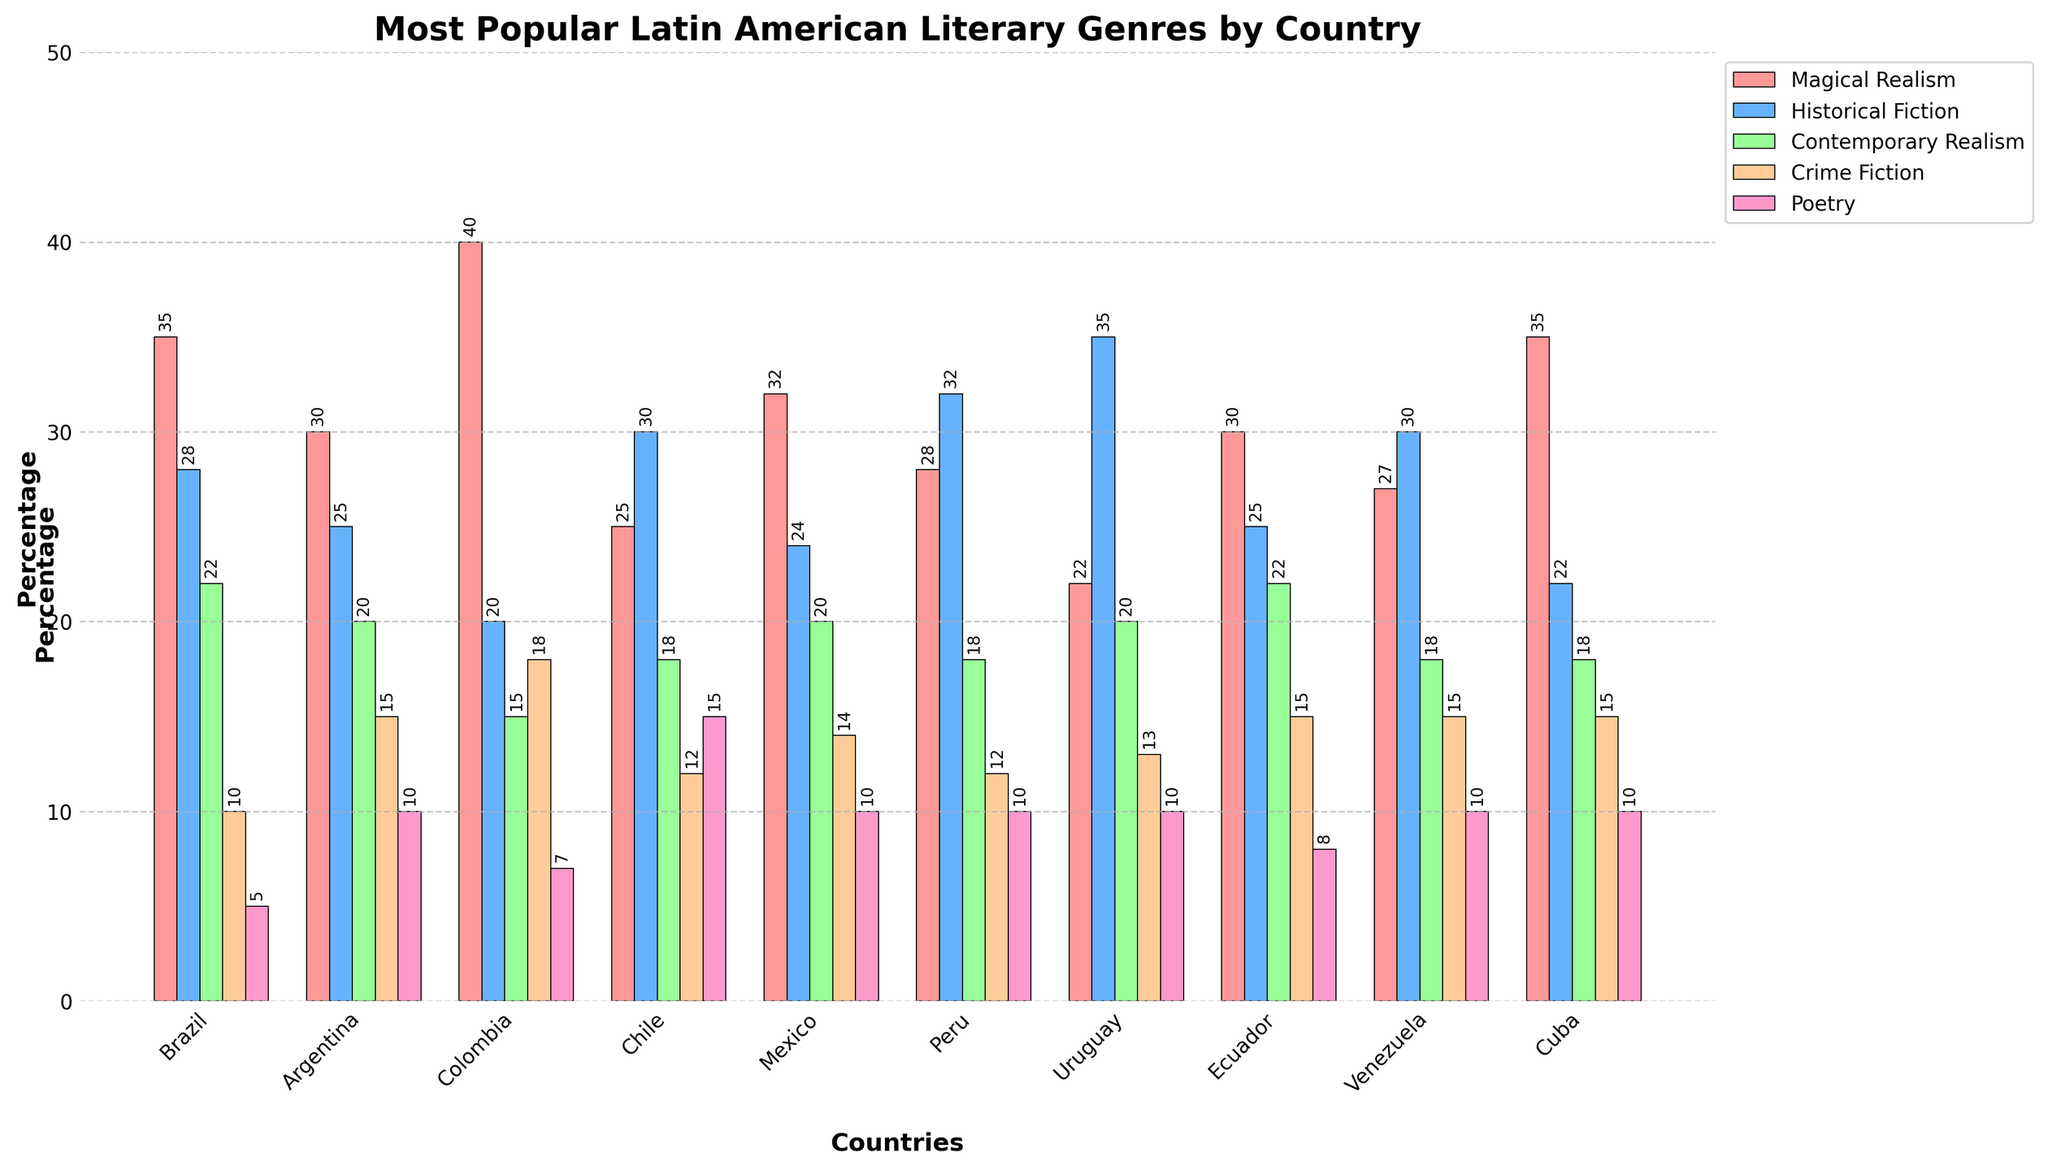Which country has the highest percentage of Magical Realism? Observing the bar with the highest value for the red color representing Magical Realism shows that Colombia has the tallest bar in this category.
Answer: Colombia How many countries have Historical Fiction as their most popular genre? Checking each country one by one for the tallest bar and its genre, we see Historical Fiction is the most popular in Chile, Peru, Uruguay, and Venezuela.
Answer: 4 Which genre is the least popular in Brazil? In Brazil, the shortest bar corresponds to Poetry (5%).
Answer: Poetry For Mexico and Argentina, which genre has a higher percentage in Mexico than in Argentina? Comparing the heights of the bars for each genre between Mexico and Argentina, only Magical Realism and Contemporary Realism have higher percentages in Mexico (Magical Realism: 32% vs 30%, Contemporary Realism: 20% vs 20%).
Answer: Magical Realism, Contemporary Realism What is the difference in percentage points between the highest and lowest genres in Colombia? Identifying the tallest and shortest bars in Colombia, the highest is Magical Realism (40%) and the lowest is Contemporary Realism (15%), the difference is 40 - 15 = 25.
Answer: 25 Which country has the highest percentage for Crime Fiction? Inspecting the bars for Crime Fiction (orange color), we can see Colombia has the highest bar at 18%.
Answer: Colombia What is the average percentage of Contemporary Realism across all countries? Summing the percentages of Contemporary Realism: 22 + 20 + 15 + 18 + 20 + 18 + 20 + 22 + 18 + 18 = 191. There are 10 countries, so the average is 191/10 = 19.1.
Answer: 19.1 If we sum the percentages of Poetry for Chile and Ecuador, what value do we get? Adding the Poetry percentages for Chile and Ecuador: 15 + 8 = 23.
Answer: 23 